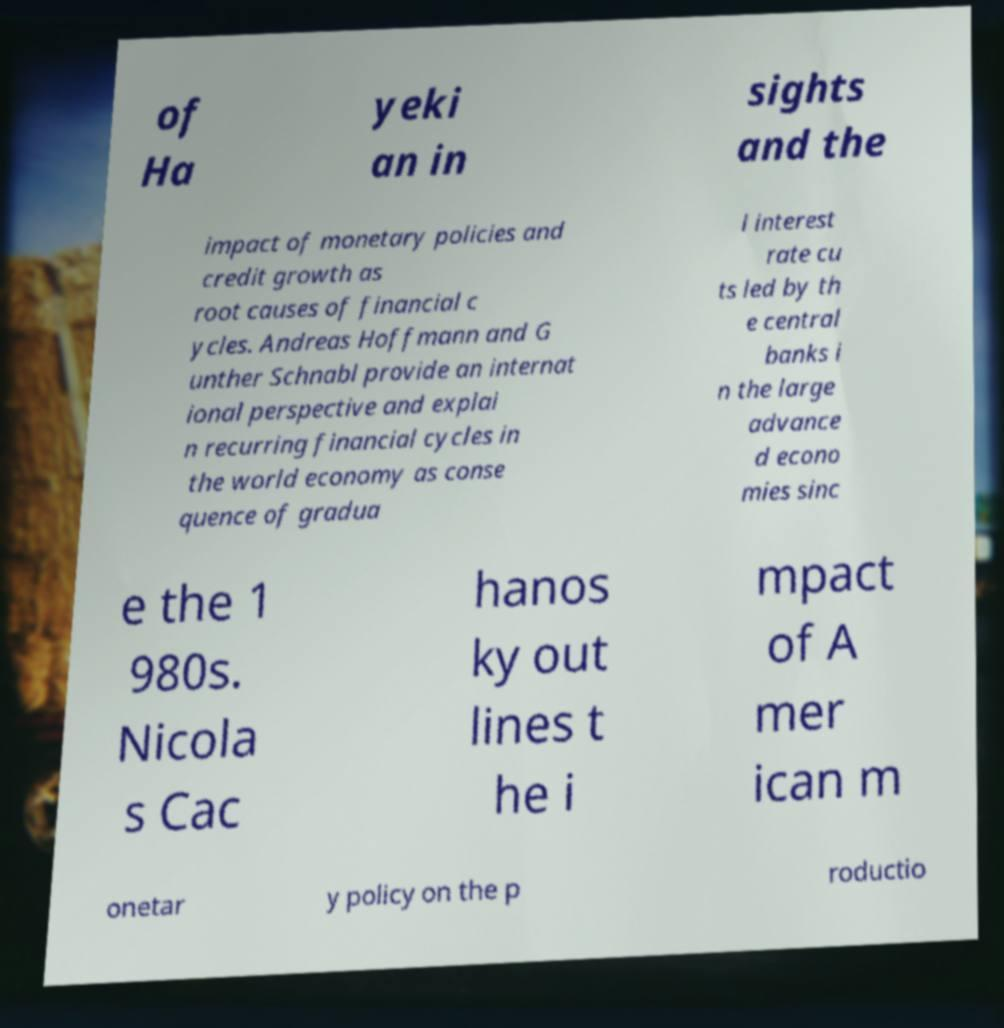Please identify and transcribe the text found in this image. of Ha yeki an in sights and the impact of monetary policies and credit growth as root causes of financial c ycles. Andreas Hoffmann and G unther Schnabl provide an internat ional perspective and explai n recurring financial cycles in the world economy as conse quence of gradua l interest rate cu ts led by th e central banks i n the large advance d econo mies sinc e the 1 980s. Nicola s Cac hanos ky out lines t he i mpact of A mer ican m onetar y policy on the p roductio 